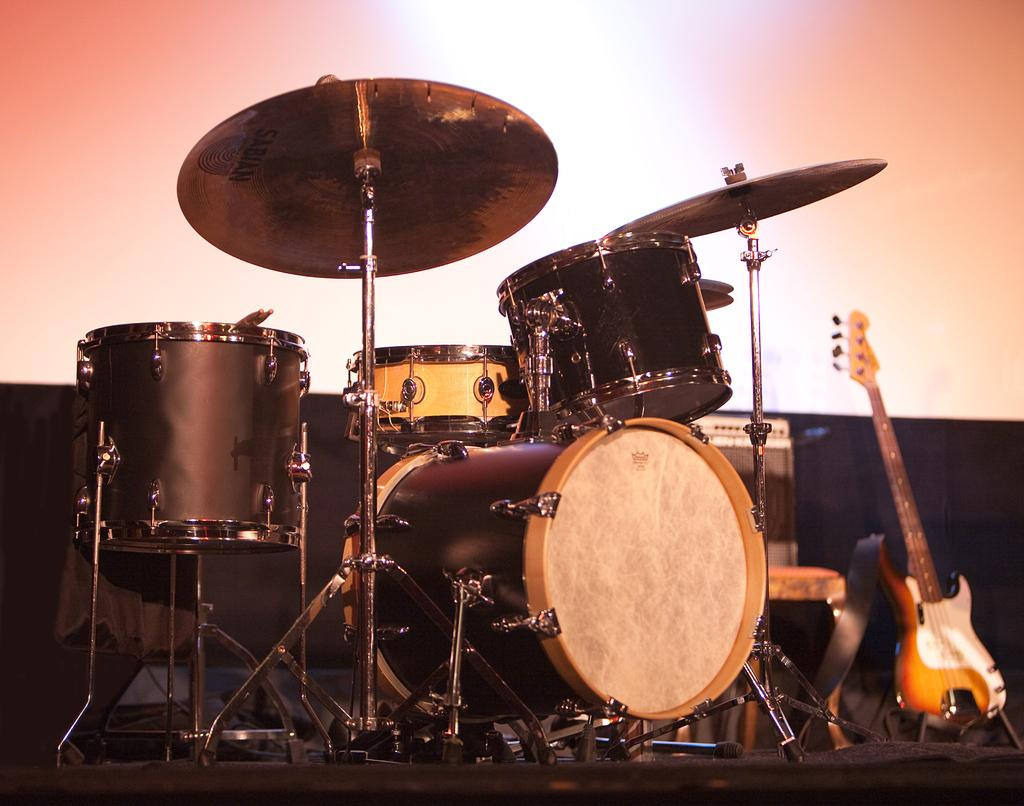What type of musical instruments are visible in the image? There are drums, a guitar, and a piano in the image. Are there any other musical instruments present? Yes, there are other musical instruments in the image. Where are the musical instruments located? The musical instruments are on a stage. What can be seen in the background of the image? There is a projector screen in the background of the image. Can you see any zebras participating in the protest on the stage in the image? There are no zebras or protests present in the image; it features musical instruments on a stage. Is anyone swimming in the image? There is no swimming activity depicted in the image; it focuses on musical instruments on a stage. 